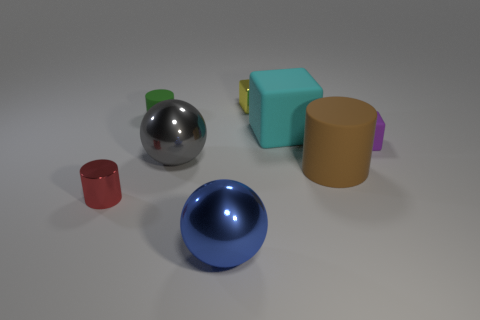Subtract all matte cylinders. How many cylinders are left? 1 Add 1 big gray matte spheres. How many objects exist? 9 Subtract all balls. How many objects are left? 6 Add 4 purple matte blocks. How many purple matte blocks exist? 5 Subtract 1 yellow blocks. How many objects are left? 7 Subtract all large metallic cubes. Subtract all tiny matte blocks. How many objects are left? 7 Add 3 metallic objects. How many metallic objects are left? 7 